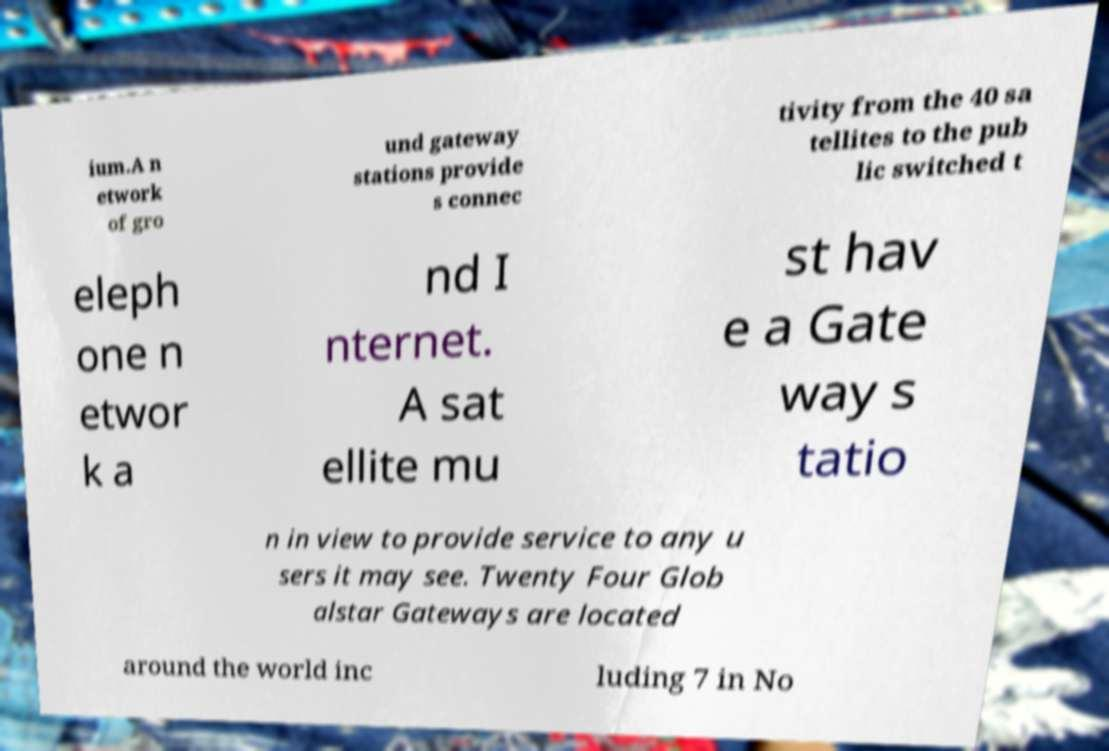Can you accurately transcribe the text from the provided image for me? ium.A n etwork of gro und gateway stations provide s connec tivity from the 40 sa tellites to the pub lic switched t eleph one n etwor k a nd I nternet. A sat ellite mu st hav e a Gate way s tatio n in view to provide service to any u sers it may see. Twenty Four Glob alstar Gateways are located around the world inc luding 7 in No 